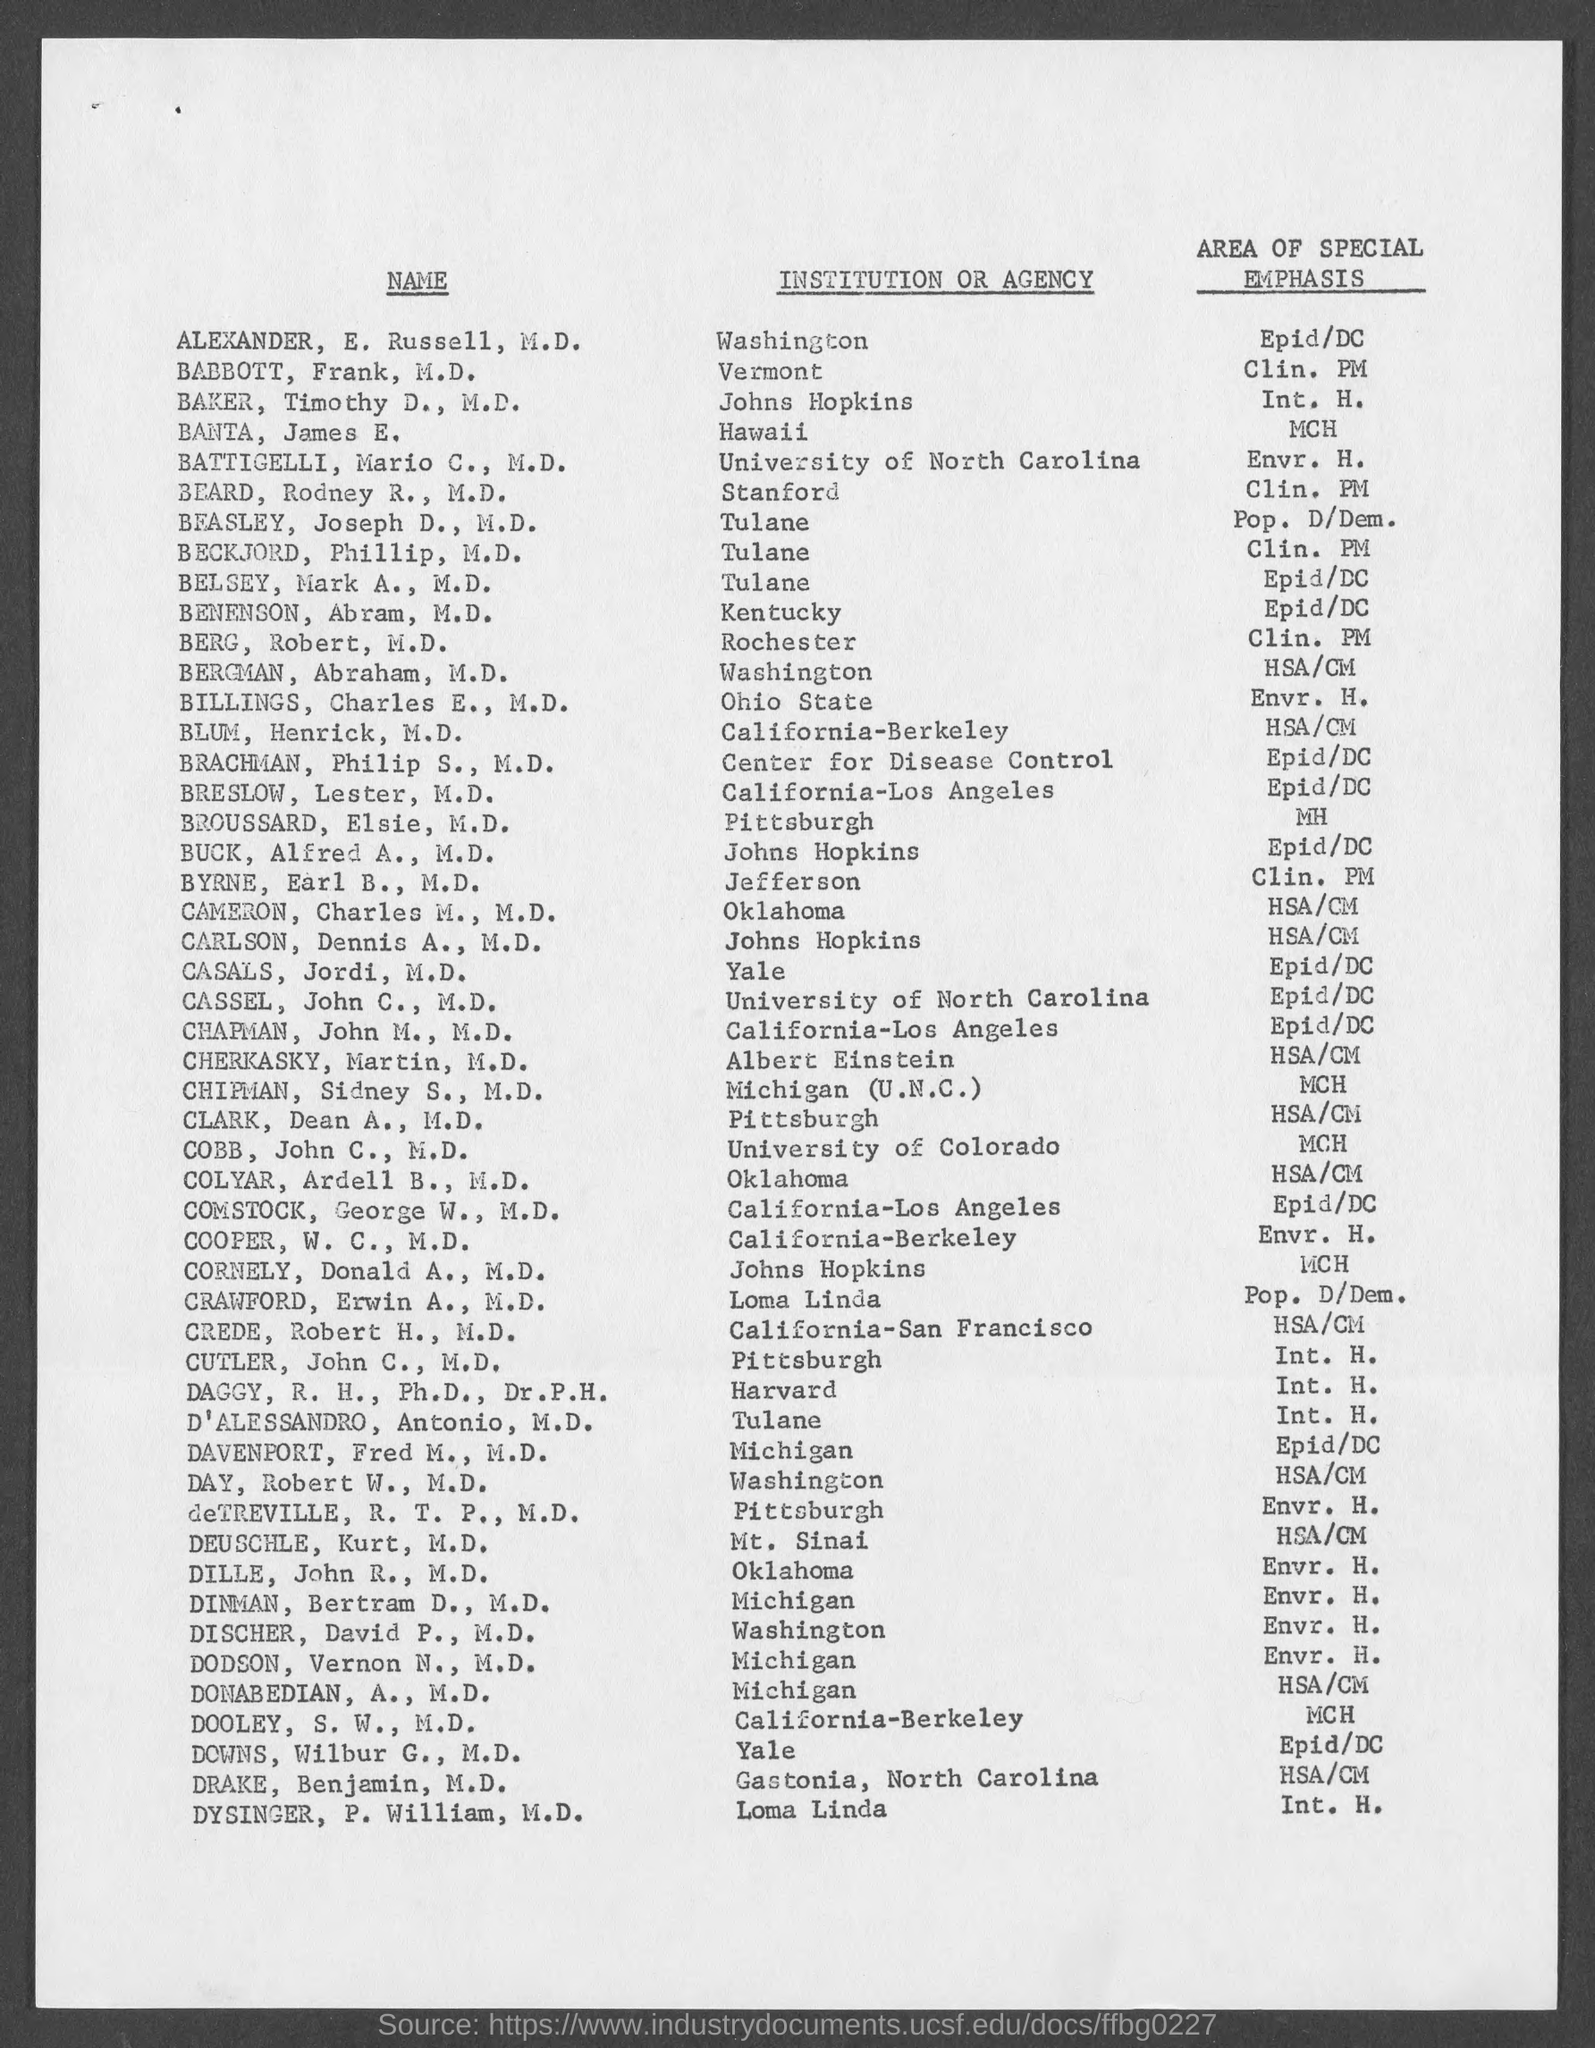Which is the institution or agency of ALEXANDER, E. Russell, M.D.?
Offer a very short reply. Washington. Who has MCH as area of special emphasis and from Hawaii?
Your answer should be compact. BANTA, James E. 